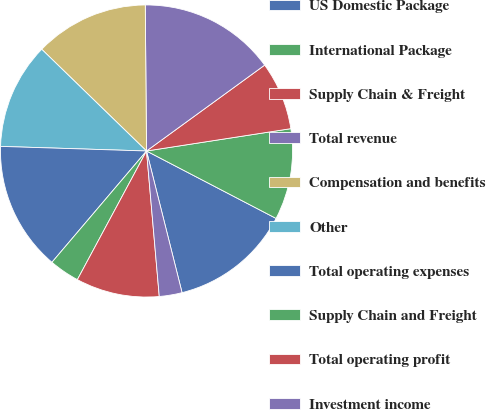<chart> <loc_0><loc_0><loc_500><loc_500><pie_chart><fcel>US Domestic Package<fcel>International Package<fcel>Supply Chain & Freight<fcel>Total revenue<fcel>Compensation and benefits<fcel>Other<fcel>Total operating expenses<fcel>Supply Chain and Freight<fcel>Total operating profit<fcel>Investment income<nl><fcel>13.45%<fcel>10.08%<fcel>7.56%<fcel>15.13%<fcel>12.6%<fcel>11.76%<fcel>14.29%<fcel>3.36%<fcel>9.24%<fcel>2.52%<nl></chart> 